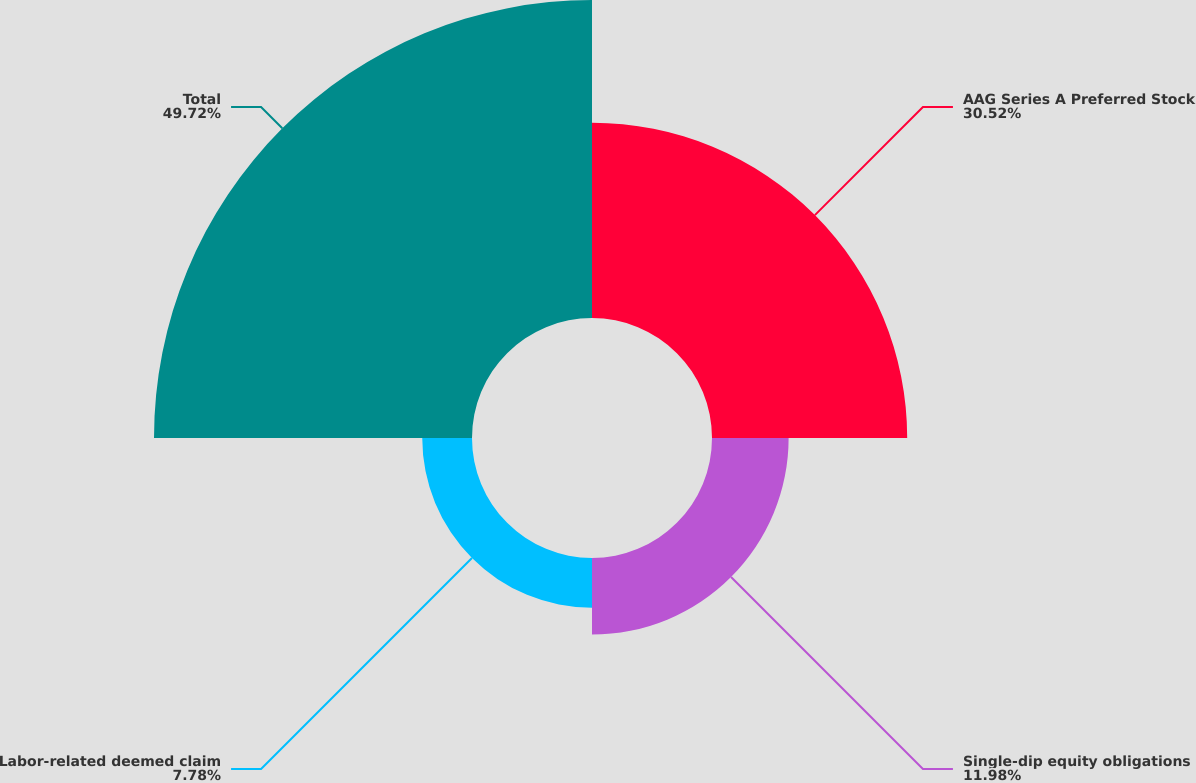Convert chart. <chart><loc_0><loc_0><loc_500><loc_500><pie_chart><fcel>AAG Series A Preferred Stock<fcel>Single-dip equity obligations<fcel>Labor-related deemed claim<fcel>Total<nl><fcel>30.52%<fcel>11.98%<fcel>7.78%<fcel>49.72%<nl></chart> 